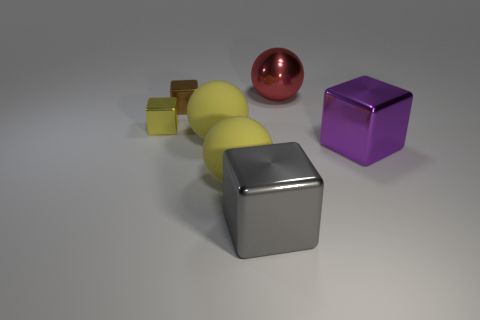Subtract 1 cubes. How many cubes are left? 3 Add 1 small blue metal cylinders. How many objects exist? 8 Subtract all spheres. How many objects are left? 4 Add 1 tiny cubes. How many tiny cubes are left? 3 Add 7 large metallic blocks. How many large metallic blocks exist? 9 Subtract 0 green cylinders. How many objects are left? 7 Subtract all yellow things. Subtract all big purple blocks. How many objects are left? 3 